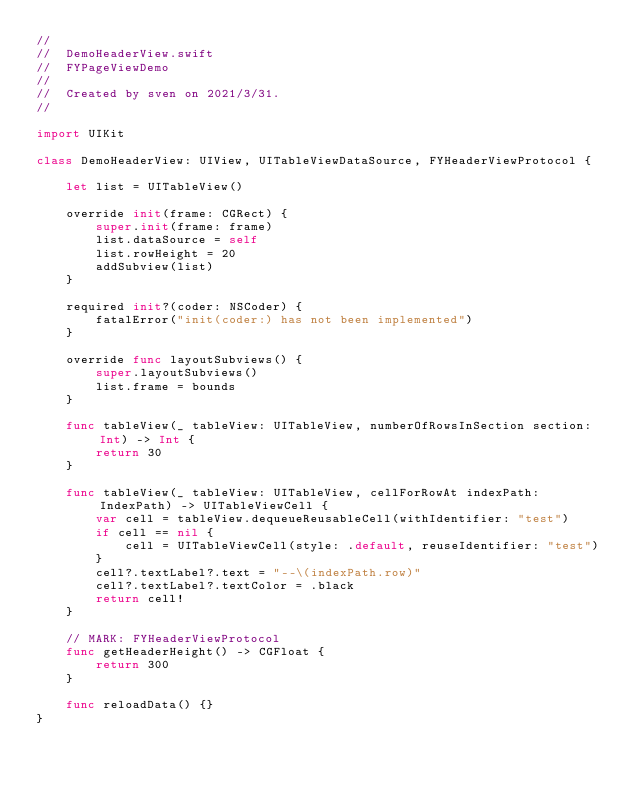<code> <loc_0><loc_0><loc_500><loc_500><_Swift_>//
//  DemoHeaderView.swift
//  FYPageViewDemo
//
//  Created by sven on 2021/3/31.
//

import UIKit

class DemoHeaderView: UIView, UITableViewDataSource, FYHeaderViewProtocol {

    let list = UITableView()

    override init(frame: CGRect) {
        super.init(frame: frame)
        list.dataSource = self
        list.rowHeight = 20
        addSubview(list)
    }

    required init?(coder: NSCoder) {
        fatalError("init(coder:) has not been implemented")
    }

    override func layoutSubviews() {
        super.layoutSubviews()
        list.frame = bounds
    }

    func tableView(_ tableView: UITableView, numberOfRowsInSection section: Int) -> Int {
        return 30
    }

    func tableView(_ tableView: UITableView, cellForRowAt indexPath: IndexPath) -> UITableViewCell {
        var cell = tableView.dequeueReusableCell(withIdentifier: "test")
        if cell == nil {
            cell = UITableViewCell(style: .default, reuseIdentifier: "test")
        }
        cell?.textLabel?.text = "--\(indexPath.row)"
        cell?.textLabel?.textColor = .black
        return cell!
    }

    // MARK: FYHeaderViewProtocol
    func getHeaderHeight() -> CGFloat {
        return 300
    }

    func reloadData() {}
}

</code> 